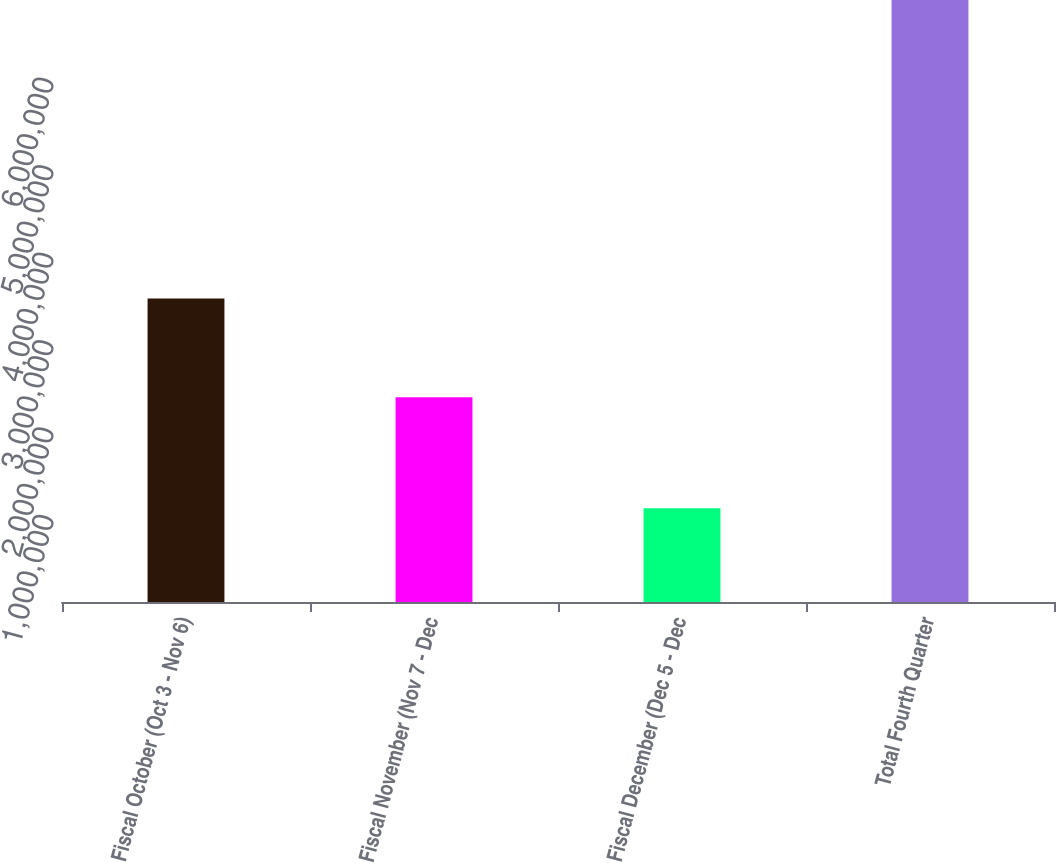Convert chart. <chart><loc_0><loc_0><loc_500><loc_500><bar_chart><fcel>Fiscal October (Oct 3 - Nov 6)<fcel>Fiscal November (Nov 7 - Dec<fcel>Fiscal December (Dec 5 - Dec<fcel>Total Fourth Quarter<nl><fcel>3.4701e+06<fcel>2.34282e+06<fcel>1.07214e+06<fcel>6.88506e+06<nl></chart> 